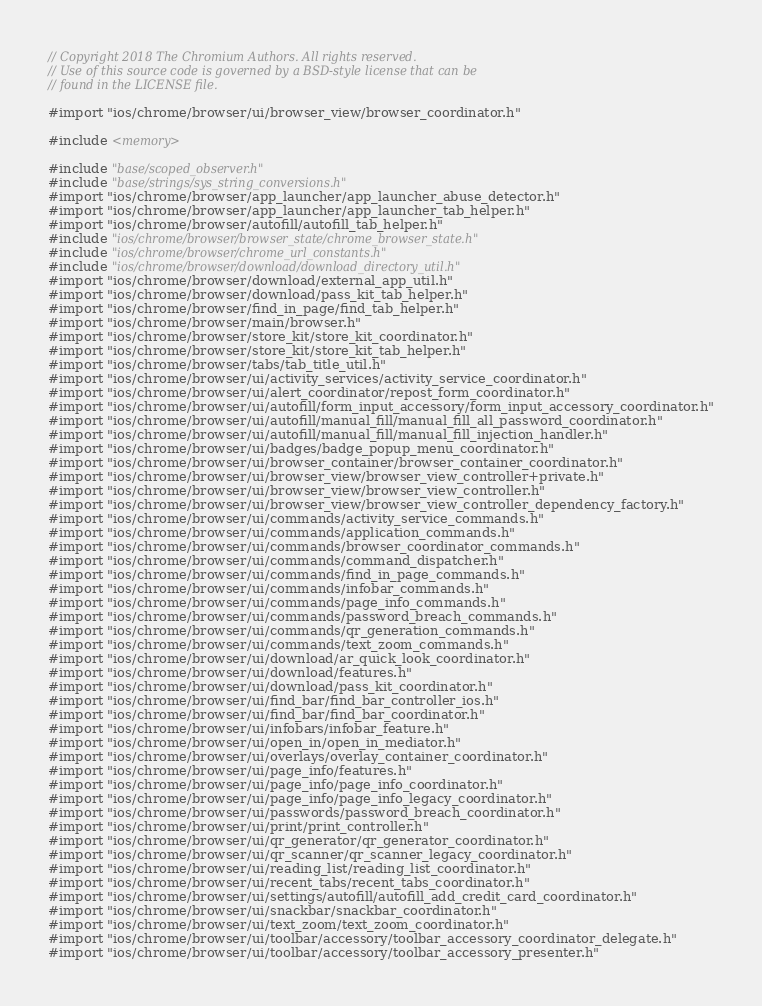Convert code to text. <code><loc_0><loc_0><loc_500><loc_500><_ObjectiveC_>// Copyright 2018 The Chromium Authors. All rights reserved.
// Use of this source code is governed by a BSD-style license that can be
// found in the LICENSE file.

#import "ios/chrome/browser/ui/browser_view/browser_coordinator.h"

#include <memory>

#include "base/scoped_observer.h"
#include "base/strings/sys_string_conversions.h"
#import "ios/chrome/browser/app_launcher/app_launcher_abuse_detector.h"
#import "ios/chrome/browser/app_launcher/app_launcher_tab_helper.h"
#import "ios/chrome/browser/autofill/autofill_tab_helper.h"
#include "ios/chrome/browser/browser_state/chrome_browser_state.h"
#include "ios/chrome/browser/chrome_url_constants.h"
#include "ios/chrome/browser/download/download_directory_util.h"
#import "ios/chrome/browser/download/external_app_util.h"
#import "ios/chrome/browser/download/pass_kit_tab_helper.h"
#import "ios/chrome/browser/find_in_page/find_tab_helper.h"
#import "ios/chrome/browser/main/browser.h"
#import "ios/chrome/browser/store_kit/store_kit_coordinator.h"
#import "ios/chrome/browser/store_kit/store_kit_tab_helper.h"
#import "ios/chrome/browser/tabs/tab_title_util.h"
#import "ios/chrome/browser/ui/activity_services/activity_service_coordinator.h"
#import "ios/chrome/browser/ui/alert_coordinator/repost_form_coordinator.h"
#import "ios/chrome/browser/ui/autofill/form_input_accessory/form_input_accessory_coordinator.h"
#import "ios/chrome/browser/ui/autofill/manual_fill/manual_fill_all_password_coordinator.h"
#import "ios/chrome/browser/ui/autofill/manual_fill/manual_fill_injection_handler.h"
#import "ios/chrome/browser/ui/badges/badge_popup_menu_coordinator.h"
#import "ios/chrome/browser/ui/browser_container/browser_container_coordinator.h"
#import "ios/chrome/browser/ui/browser_view/browser_view_controller+private.h"
#import "ios/chrome/browser/ui/browser_view/browser_view_controller.h"
#import "ios/chrome/browser/ui/browser_view/browser_view_controller_dependency_factory.h"
#import "ios/chrome/browser/ui/commands/activity_service_commands.h"
#import "ios/chrome/browser/ui/commands/application_commands.h"
#import "ios/chrome/browser/ui/commands/browser_coordinator_commands.h"
#import "ios/chrome/browser/ui/commands/command_dispatcher.h"
#import "ios/chrome/browser/ui/commands/find_in_page_commands.h"
#import "ios/chrome/browser/ui/commands/infobar_commands.h"
#import "ios/chrome/browser/ui/commands/page_info_commands.h"
#import "ios/chrome/browser/ui/commands/password_breach_commands.h"
#import "ios/chrome/browser/ui/commands/qr_generation_commands.h"
#import "ios/chrome/browser/ui/commands/text_zoom_commands.h"
#import "ios/chrome/browser/ui/download/ar_quick_look_coordinator.h"
#import "ios/chrome/browser/ui/download/features.h"
#import "ios/chrome/browser/ui/download/pass_kit_coordinator.h"
#import "ios/chrome/browser/ui/find_bar/find_bar_controller_ios.h"
#import "ios/chrome/browser/ui/find_bar/find_bar_coordinator.h"
#import "ios/chrome/browser/ui/infobars/infobar_feature.h"
#import "ios/chrome/browser/ui/open_in/open_in_mediator.h"
#import "ios/chrome/browser/ui/overlays/overlay_container_coordinator.h"
#import "ios/chrome/browser/ui/page_info/features.h"
#import "ios/chrome/browser/ui/page_info/page_info_coordinator.h"
#import "ios/chrome/browser/ui/page_info/page_info_legacy_coordinator.h"
#import "ios/chrome/browser/ui/passwords/password_breach_coordinator.h"
#import "ios/chrome/browser/ui/print/print_controller.h"
#import "ios/chrome/browser/ui/qr_generator/qr_generator_coordinator.h"
#import "ios/chrome/browser/ui/qr_scanner/qr_scanner_legacy_coordinator.h"
#import "ios/chrome/browser/ui/reading_list/reading_list_coordinator.h"
#import "ios/chrome/browser/ui/recent_tabs/recent_tabs_coordinator.h"
#import "ios/chrome/browser/ui/settings/autofill/autofill_add_credit_card_coordinator.h"
#import "ios/chrome/browser/ui/snackbar/snackbar_coordinator.h"
#import "ios/chrome/browser/ui/text_zoom/text_zoom_coordinator.h"
#import "ios/chrome/browser/ui/toolbar/accessory/toolbar_accessory_coordinator_delegate.h"
#import "ios/chrome/browser/ui/toolbar/accessory/toolbar_accessory_presenter.h"</code> 